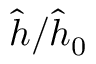<formula> <loc_0><loc_0><loc_500><loc_500>\hat { h } / \hat { h } _ { 0 }</formula> 